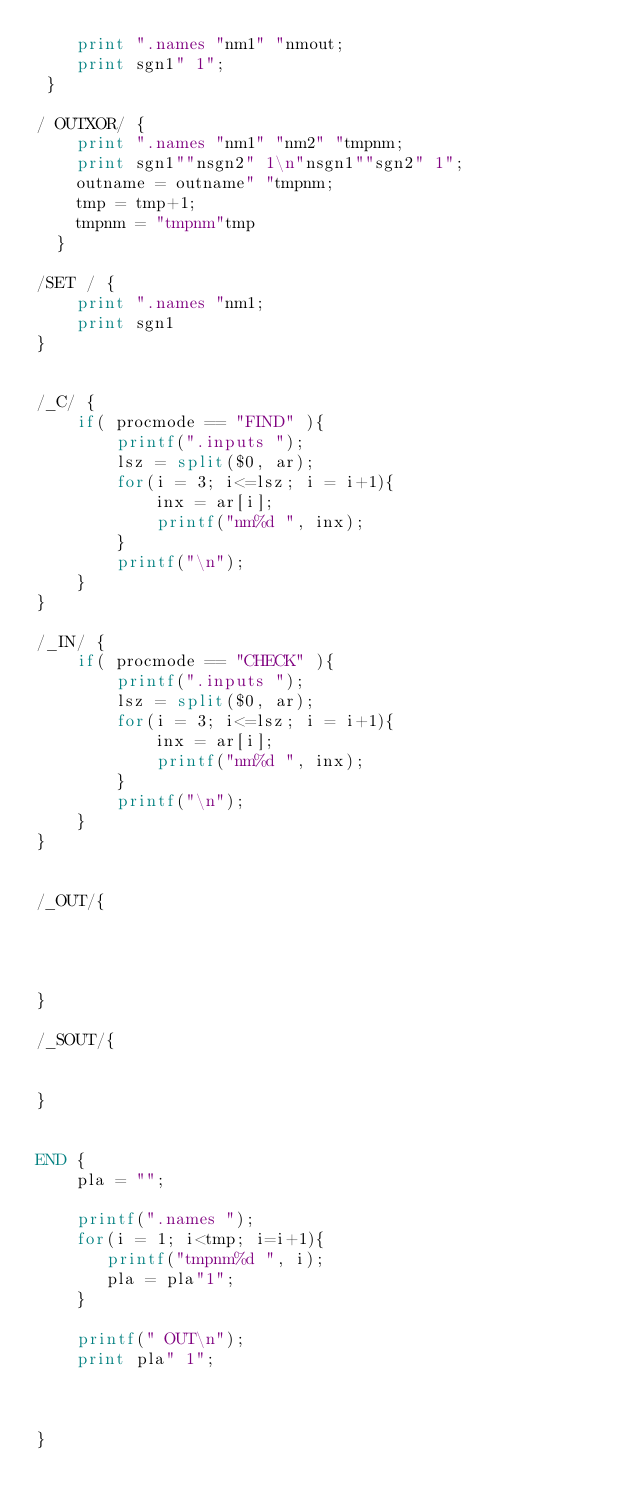Convert code to text. <code><loc_0><loc_0><loc_500><loc_500><_Awk_>	print ".names "nm1" "nmout; 
	print sgn1" 1";
 }

/ OUTXOR/ {
	print ".names "nm1" "nm2" "tmpnm;
	print sgn1""nsgn2" 1\n"nsgn1""sgn2" 1";	 
	outname = outname" "tmpnm;
	tmp = tmp+1;
	tmpnm = "tmpnm"tmp
  }

/SET / {
	print ".names "nm1;
	print sgn1
}


/_C/ {
	if( procmode == "FIND" ){	
		printf(".inputs ");
		lsz = split($0, ar);
		for(i = 3; i<=lsz; i = i+1){
			inx = ar[i];
			printf("nm%d ", inx);
		}
		printf("\n");
	}
}

/_IN/ {
	if( procmode == "CHECK" ){	
		printf(".inputs ");
		lsz = split($0, ar);
		for(i = 3; i<=lsz; i = i+1){
			inx = ar[i];
			printf("nm%d ", inx);
		}
		printf("\n");
	}
}


/_OUT/{




}

/_SOUT/{


}


END { 
	pla = "";	

	printf(".names "); 
	for(i = 1; i<tmp; i=i+1){
	   printf("tmpnm%d ", i);
	   pla = pla"1";
	}

	printf(" OUT\n");
	print pla" 1";

	

}
</code> 